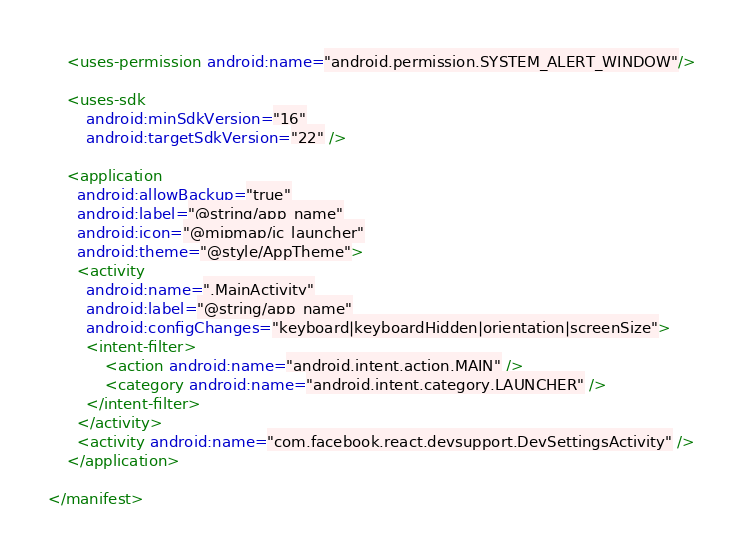<code> <loc_0><loc_0><loc_500><loc_500><_XML_>    <uses-permission android:name="android.permission.SYSTEM_ALERT_WINDOW"/>

    <uses-sdk
        android:minSdkVersion="16"
        android:targetSdkVersion="22" />

    <application
      android:allowBackup="true"
      android:label="@string/app_name"
      android:icon="@mipmap/ic_launcher"
      android:theme="@style/AppTheme">
      <activity
        android:name=".MainActivity"
        android:label="@string/app_name"
        android:configChanges="keyboard|keyboardHidden|orientation|screenSize">
        <intent-filter>
            <action android:name="android.intent.action.MAIN" />
            <category android:name="android.intent.category.LAUNCHER" />
        </intent-filter>
      </activity>
      <activity android:name="com.facebook.react.devsupport.DevSettingsActivity" />
    </application>

</manifest>
</code> 